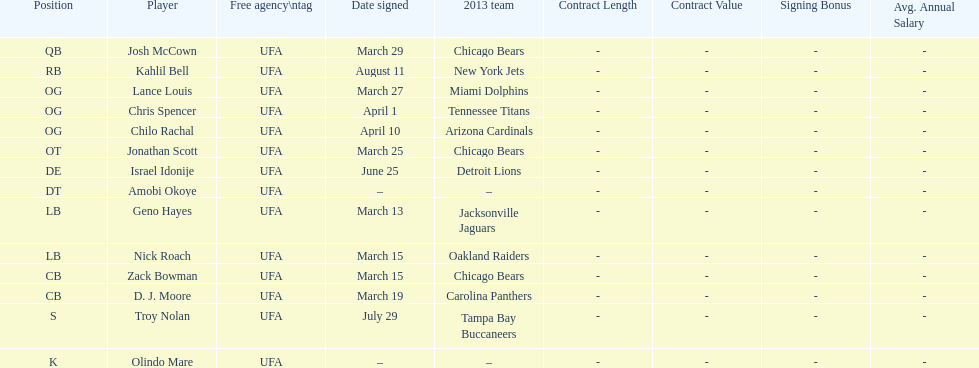What was the number of players signed during march? 7. 